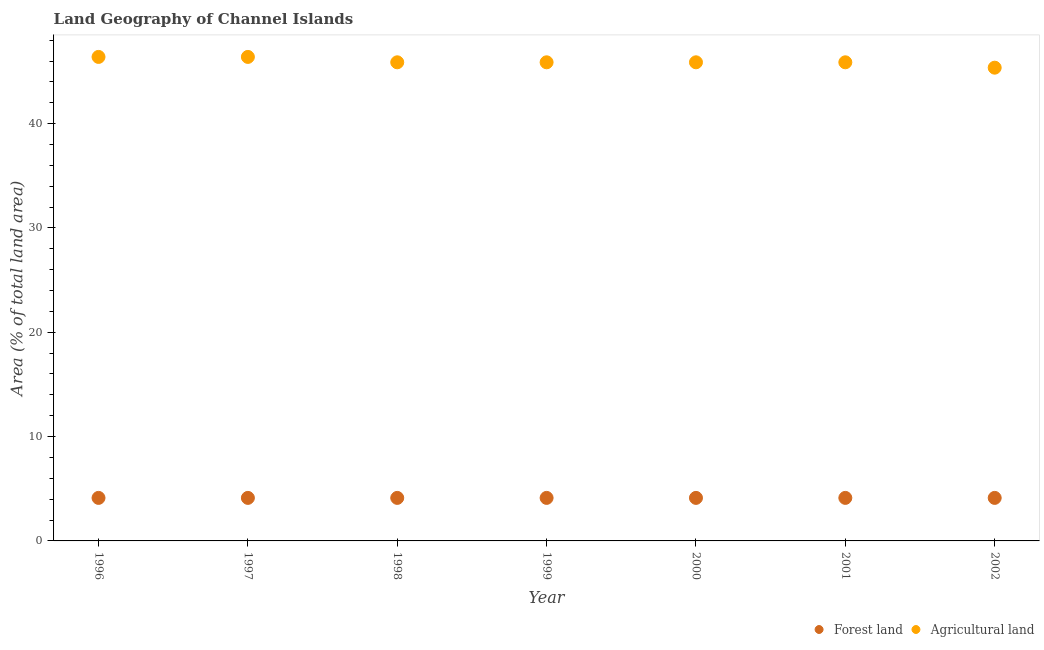Is the number of dotlines equal to the number of legend labels?
Offer a terse response. Yes. What is the percentage of land area under forests in 1998?
Offer a very short reply. 4.12. Across all years, what is the maximum percentage of land area under agriculture?
Give a very brief answer. 46.39. Across all years, what is the minimum percentage of land area under agriculture?
Provide a short and direct response. 45.36. What is the total percentage of land area under agriculture in the graph?
Offer a very short reply. 321.65. What is the difference between the percentage of land area under forests in 1998 and that in 2002?
Offer a terse response. 0. What is the difference between the percentage of land area under agriculture in 2001 and the percentage of land area under forests in 2000?
Give a very brief answer. 41.75. What is the average percentage of land area under agriculture per year?
Your answer should be very brief. 45.95. In the year 2001, what is the difference between the percentage of land area under agriculture and percentage of land area under forests?
Give a very brief answer. 41.75. In how many years, is the percentage of land area under agriculture greater than 28 %?
Provide a short and direct response. 7. Is the percentage of land area under agriculture in 1998 less than that in 2002?
Offer a terse response. No. What is the difference between the highest and the lowest percentage of land area under agriculture?
Your response must be concise. 1.03. Is the percentage of land area under forests strictly greater than the percentage of land area under agriculture over the years?
Provide a succinct answer. No. How many years are there in the graph?
Your response must be concise. 7. Does the graph contain grids?
Give a very brief answer. No. Where does the legend appear in the graph?
Keep it short and to the point. Bottom right. How many legend labels are there?
Give a very brief answer. 2. How are the legend labels stacked?
Offer a very short reply. Horizontal. What is the title of the graph?
Keep it short and to the point. Land Geography of Channel Islands. Does "Forest" appear as one of the legend labels in the graph?
Keep it short and to the point. No. What is the label or title of the Y-axis?
Your answer should be compact. Area (% of total land area). What is the Area (% of total land area) of Forest land in 1996?
Your response must be concise. 4.12. What is the Area (% of total land area) in Agricultural land in 1996?
Provide a short and direct response. 46.39. What is the Area (% of total land area) of Forest land in 1997?
Give a very brief answer. 4.12. What is the Area (% of total land area) of Agricultural land in 1997?
Give a very brief answer. 46.39. What is the Area (% of total land area) in Forest land in 1998?
Offer a terse response. 4.12. What is the Area (% of total land area) in Agricultural land in 1998?
Offer a terse response. 45.88. What is the Area (% of total land area) in Forest land in 1999?
Keep it short and to the point. 4.12. What is the Area (% of total land area) in Agricultural land in 1999?
Give a very brief answer. 45.88. What is the Area (% of total land area) in Forest land in 2000?
Ensure brevity in your answer.  4.12. What is the Area (% of total land area) in Agricultural land in 2000?
Your answer should be compact. 45.88. What is the Area (% of total land area) in Forest land in 2001?
Your response must be concise. 4.12. What is the Area (% of total land area) in Agricultural land in 2001?
Keep it short and to the point. 45.88. What is the Area (% of total land area) of Forest land in 2002?
Keep it short and to the point. 4.12. What is the Area (% of total land area) in Agricultural land in 2002?
Make the answer very short. 45.36. Across all years, what is the maximum Area (% of total land area) in Forest land?
Your response must be concise. 4.12. Across all years, what is the maximum Area (% of total land area) in Agricultural land?
Make the answer very short. 46.39. Across all years, what is the minimum Area (% of total land area) of Forest land?
Offer a terse response. 4.12. Across all years, what is the minimum Area (% of total land area) in Agricultural land?
Your response must be concise. 45.36. What is the total Area (% of total land area) in Forest land in the graph?
Give a very brief answer. 28.87. What is the total Area (% of total land area) of Agricultural land in the graph?
Offer a very short reply. 321.65. What is the difference between the Area (% of total land area) in Agricultural land in 1996 and that in 1998?
Offer a very short reply. 0.52. What is the difference between the Area (% of total land area) in Agricultural land in 1996 and that in 1999?
Provide a succinct answer. 0.52. What is the difference between the Area (% of total land area) in Agricultural land in 1996 and that in 2000?
Offer a very short reply. 0.52. What is the difference between the Area (% of total land area) in Agricultural land in 1996 and that in 2001?
Offer a terse response. 0.52. What is the difference between the Area (% of total land area) of Agricultural land in 1996 and that in 2002?
Offer a terse response. 1.03. What is the difference between the Area (% of total land area) of Agricultural land in 1997 and that in 1998?
Your response must be concise. 0.52. What is the difference between the Area (% of total land area) of Forest land in 1997 and that in 1999?
Make the answer very short. 0. What is the difference between the Area (% of total land area) in Agricultural land in 1997 and that in 1999?
Give a very brief answer. 0.52. What is the difference between the Area (% of total land area) of Agricultural land in 1997 and that in 2000?
Provide a succinct answer. 0.52. What is the difference between the Area (% of total land area) in Forest land in 1997 and that in 2001?
Your response must be concise. 0. What is the difference between the Area (% of total land area) in Agricultural land in 1997 and that in 2001?
Make the answer very short. 0.52. What is the difference between the Area (% of total land area) of Forest land in 1997 and that in 2002?
Provide a succinct answer. 0. What is the difference between the Area (% of total land area) in Agricultural land in 1997 and that in 2002?
Your answer should be compact. 1.03. What is the difference between the Area (% of total land area) of Agricultural land in 1998 and that in 1999?
Keep it short and to the point. 0. What is the difference between the Area (% of total land area) of Forest land in 1998 and that in 2000?
Your answer should be very brief. 0. What is the difference between the Area (% of total land area) in Agricultural land in 1998 and that in 2000?
Offer a very short reply. 0. What is the difference between the Area (% of total land area) of Forest land in 1998 and that in 2001?
Your answer should be compact. 0. What is the difference between the Area (% of total land area) of Agricultural land in 1998 and that in 2001?
Keep it short and to the point. 0. What is the difference between the Area (% of total land area) of Agricultural land in 1998 and that in 2002?
Offer a terse response. 0.52. What is the difference between the Area (% of total land area) in Agricultural land in 1999 and that in 2000?
Ensure brevity in your answer.  0. What is the difference between the Area (% of total land area) of Agricultural land in 1999 and that in 2001?
Keep it short and to the point. 0. What is the difference between the Area (% of total land area) of Forest land in 1999 and that in 2002?
Keep it short and to the point. 0. What is the difference between the Area (% of total land area) in Agricultural land in 1999 and that in 2002?
Ensure brevity in your answer.  0.52. What is the difference between the Area (% of total land area) in Forest land in 2000 and that in 2001?
Your response must be concise. 0. What is the difference between the Area (% of total land area) in Agricultural land in 2000 and that in 2001?
Ensure brevity in your answer.  0. What is the difference between the Area (% of total land area) of Agricultural land in 2000 and that in 2002?
Keep it short and to the point. 0.52. What is the difference between the Area (% of total land area) of Agricultural land in 2001 and that in 2002?
Provide a succinct answer. 0.52. What is the difference between the Area (% of total land area) in Forest land in 1996 and the Area (% of total land area) in Agricultural land in 1997?
Offer a very short reply. -42.27. What is the difference between the Area (% of total land area) in Forest land in 1996 and the Area (% of total land area) in Agricultural land in 1998?
Your answer should be compact. -41.75. What is the difference between the Area (% of total land area) in Forest land in 1996 and the Area (% of total land area) in Agricultural land in 1999?
Your answer should be very brief. -41.75. What is the difference between the Area (% of total land area) in Forest land in 1996 and the Area (% of total land area) in Agricultural land in 2000?
Your response must be concise. -41.75. What is the difference between the Area (% of total land area) of Forest land in 1996 and the Area (% of total land area) of Agricultural land in 2001?
Offer a very short reply. -41.75. What is the difference between the Area (% of total land area) in Forest land in 1996 and the Area (% of total land area) in Agricultural land in 2002?
Provide a succinct answer. -41.24. What is the difference between the Area (% of total land area) of Forest land in 1997 and the Area (% of total land area) of Agricultural land in 1998?
Your answer should be very brief. -41.75. What is the difference between the Area (% of total land area) in Forest land in 1997 and the Area (% of total land area) in Agricultural land in 1999?
Make the answer very short. -41.75. What is the difference between the Area (% of total land area) in Forest land in 1997 and the Area (% of total land area) in Agricultural land in 2000?
Offer a terse response. -41.75. What is the difference between the Area (% of total land area) in Forest land in 1997 and the Area (% of total land area) in Agricultural land in 2001?
Your response must be concise. -41.75. What is the difference between the Area (% of total land area) in Forest land in 1997 and the Area (% of total land area) in Agricultural land in 2002?
Offer a terse response. -41.24. What is the difference between the Area (% of total land area) of Forest land in 1998 and the Area (% of total land area) of Agricultural land in 1999?
Ensure brevity in your answer.  -41.75. What is the difference between the Area (% of total land area) of Forest land in 1998 and the Area (% of total land area) of Agricultural land in 2000?
Offer a very short reply. -41.75. What is the difference between the Area (% of total land area) in Forest land in 1998 and the Area (% of total land area) in Agricultural land in 2001?
Your answer should be very brief. -41.75. What is the difference between the Area (% of total land area) in Forest land in 1998 and the Area (% of total land area) in Agricultural land in 2002?
Offer a terse response. -41.24. What is the difference between the Area (% of total land area) in Forest land in 1999 and the Area (% of total land area) in Agricultural land in 2000?
Offer a very short reply. -41.75. What is the difference between the Area (% of total land area) in Forest land in 1999 and the Area (% of total land area) in Agricultural land in 2001?
Provide a succinct answer. -41.75. What is the difference between the Area (% of total land area) in Forest land in 1999 and the Area (% of total land area) in Agricultural land in 2002?
Offer a very short reply. -41.24. What is the difference between the Area (% of total land area) in Forest land in 2000 and the Area (% of total land area) in Agricultural land in 2001?
Your response must be concise. -41.75. What is the difference between the Area (% of total land area) of Forest land in 2000 and the Area (% of total land area) of Agricultural land in 2002?
Offer a terse response. -41.24. What is the difference between the Area (% of total land area) in Forest land in 2001 and the Area (% of total land area) in Agricultural land in 2002?
Your answer should be compact. -41.24. What is the average Area (% of total land area) in Forest land per year?
Your response must be concise. 4.12. What is the average Area (% of total land area) in Agricultural land per year?
Keep it short and to the point. 45.95. In the year 1996, what is the difference between the Area (% of total land area) in Forest land and Area (% of total land area) in Agricultural land?
Ensure brevity in your answer.  -42.27. In the year 1997, what is the difference between the Area (% of total land area) in Forest land and Area (% of total land area) in Agricultural land?
Offer a terse response. -42.27. In the year 1998, what is the difference between the Area (% of total land area) in Forest land and Area (% of total land area) in Agricultural land?
Keep it short and to the point. -41.75. In the year 1999, what is the difference between the Area (% of total land area) of Forest land and Area (% of total land area) of Agricultural land?
Ensure brevity in your answer.  -41.75. In the year 2000, what is the difference between the Area (% of total land area) of Forest land and Area (% of total land area) of Agricultural land?
Your answer should be compact. -41.75. In the year 2001, what is the difference between the Area (% of total land area) of Forest land and Area (% of total land area) of Agricultural land?
Make the answer very short. -41.75. In the year 2002, what is the difference between the Area (% of total land area) of Forest land and Area (% of total land area) of Agricultural land?
Give a very brief answer. -41.24. What is the ratio of the Area (% of total land area) of Forest land in 1996 to that in 1997?
Provide a succinct answer. 1. What is the ratio of the Area (% of total land area) of Agricultural land in 1996 to that in 1997?
Provide a succinct answer. 1. What is the ratio of the Area (% of total land area) of Agricultural land in 1996 to that in 1998?
Provide a short and direct response. 1.01. What is the ratio of the Area (% of total land area) in Forest land in 1996 to that in 1999?
Give a very brief answer. 1. What is the ratio of the Area (% of total land area) of Agricultural land in 1996 to that in 1999?
Offer a terse response. 1.01. What is the ratio of the Area (% of total land area) in Agricultural land in 1996 to that in 2000?
Provide a short and direct response. 1.01. What is the ratio of the Area (% of total land area) in Forest land in 1996 to that in 2001?
Your response must be concise. 1. What is the ratio of the Area (% of total land area) of Agricultural land in 1996 to that in 2001?
Offer a very short reply. 1.01. What is the ratio of the Area (% of total land area) in Agricultural land in 1996 to that in 2002?
Give a very brief answer. 1.02. What is the ratio of the Area (% of total land area) in Forest land in 1997 to that in 1998?
Your answer should be compact. 1. What is the ratio of the Area (% of total land area) of Agricultural land in 1997 to that in 1998?
Provide a succinct answer. 1.01. What is the ratio of the Area (% of total land area) in Agricultural land in 1997 to that in 1999?
Make the answer very short. 1.01. What is the ratio of the Area (% of total land area) of Forest land in 1997 to that in 2000?
Give a very brief answer. 1. What is the ratio of the Area (% of total land area) in Agricultural land in 1997 to that in 2000?
Give a very brief answer. 1.01. What is the ratio of the Area (% of total land area) of Agricultural land in 1997 to that in 2001?
Ensure brevity in your answer.  1.01. What is the ratio of the Area (% of total land area) of Agricultural land in 1997 to that in 2002?
Make the answer very short. 1.02. What is the ratio of the Area (% of total land area) of Forest land in 1998 to that in 1999?
Make the answer very short. 1. What is the ratio of the Area (% of total land area) of Agricultural land in 1998 to that in 1999?
Your response must be concise. 1. What is the ratio of the Area (% of total land area) of Forest land in 1998 to that in 2000?
Your answer should be compact. 1. What is the ratio of the Area (% of total land area) in Agricultural land in 1998 to that in 2000?
Offer a terse response. 1. What is the ratio of the Area (% of total land area) in Forest land in 1998 to that in 2002?
Offer a very short reply. 1. What is the ratio of the Area (% of total land area) in Agricultural land in 1998 to that in 2002?
Offer a very short reply. 1.01. What is the ratio of the Area (% of total land area) of Forest land in 1999 to that in 2002?
Offer a very short reply. 1. What is the ratio of the Area (% of total land area) of Agricultural land in 1999 to that in 2002?
Your answer should be compact. 1.01. What is the ratio of the Area (% of total land area) in Forest land in 2000 to that in 2001?
Keep it short and to the point. 1. What is the ratio of the Area (% of total land area) in Agricultural land in 2000 to that in 2002?
Ensure brevity in your answer.  1.01. What is the ratio of the Area (% of total land area) of Forest land in 2001 to that in 2002?
Keep it short and to the point. 1. What is the ratio of the Area (% of total land area) of Agricultural land in 2001 to that in 2002?
Your answer should be very brief. 1.01. What is the difference between the highest and the second highest Area (% of total land area) of Forest land?
Keep it short and to the point. 0. What is the difference between the highest and the second highest Area (% of total land area) in Agricultural land?
Give a very brief answer. 0. What is the difference between the highest and the lowest Area (% of total land area) in Forest land?
Your answer should be very brief. 0. What is the difference between the highest and the lowest Area (% of total land area) in Agricultural land?
Provide a short and direct response. 1.03. 